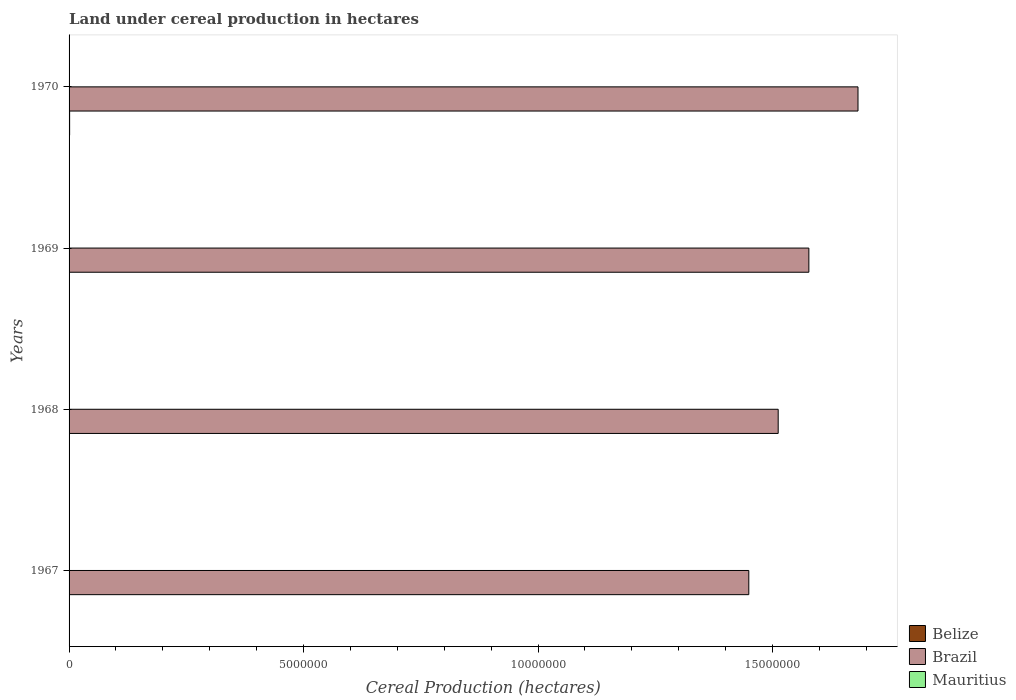How many different coloured bars are there?
Make the answer very short. 3. How many groups of bars are there?
Offer a very short reply. 4. Are the number of bars per tick equal to the number of legend labels?
Provide a succinct answer. Yes. How many bars are there on the 2nd tick from the top?
Ensure brevity in your answer.  3. How many bars are there on the 2nd tick from the bottom?
Ensure brevity in your answer.  3. What is the label of the 3rd group of bars from the top?
Provide a short and direct response. 1968. What is the land under cereal production in Mauritius in 1968?
Make the answer very short. 205. Across all years, what is the maximum land under cereal production in Brazil?
Provide a succinct answer. 1.68e+07. Across all years, what is the minimum land under cereal production in Belize?
Provide a short and direct response. 8102. In which year was the land under cereal production in Mauritius minimum?
Your response must be concise. 1968. What is the total land under cereal production in Belize in the graph?
Offer a very short reply. 3.72e+04. What is the difference between the land under cereal production in Belize in 1968 and that in 1969?
Provide a succinct answer. -375. What is the difference between the land under cereal production in Mauritius in 1967 and the land under cereal production in Belize in 1969?
Your answer should be compact. -8517. What is the average land under cereal production in Mauritius per year?
Keep it short and to the point. 359. In the year 1968, what is the difference between the land under cereal production in Brazil and land under cereal production in Belize?
Offer a terse response. 1.51e+07. In how many years, is the land under cereal production in Brazil greater than 3000000 hectares?
Keep it short and to the point. 4. What is the ratio of the land under cereal production in Mauritius in 1967 to that in 1968?
Your answer should be compact. 1.31. What is the difference between the highest and the second highest land under cereal production in Brazil?
Give a very brief answer. 1.05e+06. What is the difference between the highest and the lowest land under cereal production in Belize?
Ensure brevity in your answer.  3790. Is the sum of the land under cereal production in Mauritius in 1968 and 1969 greater than the maximum land under cereal production in Belize across all years?
Give a very brief answer. No. What does the 2nd bar from the top in 1969 represents?
Provide a short and direct response. Brazil. What does the 1st bar from the bottom in 1967 represents?
Your response must be concise. Belize. How many bars are there?
Provide a succinct answer. 12. How many years are there in the graph?
Keep it short and to the point. 4. Are the values on the major ticks of X-axis written in scientific E-notation?
Ensure brevity in your answer.  No. How many legend labels are there?
Offer a very short reply. 3. How are the legend labels stacked?
Offer a very short reply. Vertical. What is the title of the graph?
Offer a very short reply. Land under cereal production in hectares. Does "Slovak Republic" appear as one of the legend labels in the graph?
Provide a succinct answer. No. What is the label or title of the X-axis?
Make the answer very short. Cereal Production (hectares). What is the Cereal Production (hectares) of Belize in 1967?
Keep it short and to the point. 8102. What is the Cereal Production (hectares) of Brazil in 1967?
Ensure brevity in your answer.  1.45e+07. What is the Cereal Production (hectares) in Mauritius in 1967?
Ensure brevity in your answer.  268. What is the Cereal Production (hectares) of Belize in 1968?
Ensure brevity in your answer.  8410. What is the Cereal Production (hectares) of Brazil in 1968?
Your answer should be very brief. 1.51e+07. What is the Cereal Production (hectares) in Mauritius in 1968?
Provide a succinct answer. 205. What is the Cereal Production (hectares) in Belize in 1969?
Provide a succinct answer. 8785. What is the Cereal Production (hectares) in Brazil in 1969?
Give a very brief answer. 1.58e+07. What is the Cereal Production (hectares) in Mauritius in 1969?
Keep it short and to the point. 446. What is the Cereal Production (hectares) in Belize in 1970?
Make the answer very short. 1.19e+04. What is the Cereal Production (hectares) of Brazil in 1970?
Offer a terse response. 1.68e+07. What is the Cereal Production (hectares) of Mauritius in 1970?
Make the answer very short. 517. Across all years, what is the maximum Cereal Production (hectares) of Belize?
Make the answer very short. 1.19e+04. Across all years, what is the maximum Cereal Production (hectares) of Brazil?
Ensure brevity in your answer.  1.68e+07. Across all years, what is the maximum Cereal Production (hectares) in Mauritius?
Provide a short and direct response. 517. Across all years, what is the minimum Cereal Production (hectares) in Belize?
Offer a terse response. 8102. Across all years, what is the minimum Cereal Production (hectares) of Brazil?
Offer a terse response. 1.45e+07. Across all years, what is the minimum Cereal Production (hectares) in Mauritius?
Your response must be concise. 205. What is the total Cereal Production (hectares) in Belize in the graph?
Your answer should be compact. 3.72e+04. What is the total Cereal Production (hectares) of Brazil in the graph?
Give a very brief answer. 6.22e+07. What is the total Cereal Production (hectares) of Mauritius in the graph?
Give a very brief answer. 1436. What is the difference between the Cereal Production (hectares) of Belize in 1967 and that in 1968?
Offer a terse response. -308. What is the difference between the Cereal Production (hectares) of Brazil in 1967 and that in 1968?
Ensure brevity in your answer.  -6.27e+05. What is the difference between the Cereal Production (hectares) in Belize in 1967 and that in 1969?
Make the answer very short. -683. What is the difference between the Cereal Production (hectares) in Brazil in 1967 and that in 1969?
Keep it short and to the point. -1.28e+06. What is the difference between the Cereal Production (hectares) in Mauritius in 1967 and that in 1969?
Make the answer very short. -178. What is the difference between the Cereal Production (hectares) in Belize in 1967 and that in 1970?
Keep it short and to the point. -3790. What is the difference between the Cereal Production (hectares) of Brazil in 1967 and that in 1970?
Make the answer very short. -2.33e+06. What is the difference between the Cereal Production (hectares) of Mauritius in 1967 and that in 1970?
Your answer should be very brief. -249. What is the difference between the Cereal Production (hectares) of Belize in 1968 and that in 1969?
Keep it short and to the point. -375. What is the difference between the Cereal Production (hectares) in Brazil in 1968 and that in 1969?
Your response must be concise. -6.54e+05. What is the difference between the Cereal Production (hectares) of Mauritius in 1968 and that in 1969?
Your answer should be compact. -241. What is the difference between the Cereal Production (hectares) in Belize in 1968 and that in 1970?
Give a very brief answer. -3482. What is the difference between the Cereal Production (hectares) in Brazil in 1968 and that in 1970?
Keep it short and to the point. -1.70e+06. What is the difference between the Cereal Production (hectares) in Mauritius in 1968 and that in 1970?
Provide a succinct answer. -312. What is the difference between the Cereal Production (hectares) of Belize in 1969 and that in 1970?
Offer a very short reply. -3107. What is the difference between the Cereal Production (hectares) of Brazil in 1969 and that in 1970?
Offer a very short reply. -1.05e+06. What is the difference between the Cereal Production (hectares) in Mauritius in 1969 and that in 1970?
Offer a very short reply. -71. What is the difference between the Cereal Production (hectares) in Belize in 1967 and the Cereal Production (hectares) in Brazil in 1968?
Your response must be concise. -1.51e+07. What is the difference between the Cereal Production (hectares) of Belize in 1967 and the Cereal Production (hectares) of Mauritius in 1968?
Your response must be concise. 7897. What is the difference between the Cereal Production (hectares) of Brazil in 1967 and the Cereal Production (hectares) of Mauritius in 1968?
Provide a succinct answer. 1.45e+07. What is the difference between the Cereal Production (hectares) of Belize in 1967 and the Cereal Production (hectares) of Brazil in 1969?
Your answer should be very brief. -1.58e+07. What is the difference between the Cereal Production (hectares) of Belize in 1967 and the Cereal Production (hectares) of Mauritius in 1969?
Your response must be concise. 7656. What is the difference between the Cereal Production (hectares) in Brazil in 1967 and the Cereal Production (hectares) in Mauritius in 1969?
Ensure brevity in your answer.  1.45e+07. What is the difference between the Cereal Production (hectares) of Belize in 1967 and the Cereal Production (hectares) of Brazil in 1970?
Provide a succinct answer. -1.68e+07. What is the difference between the Cereal Production (hectares) in Belize in 1967 and the Cereal Production (hectares) in Mauritius in 1970?
Offer a terse response. 7585. What is the difference between the Cereal Production (hectares) in Brazil in 1967 and the Cereal Production (hectares) in Mauritius in 1970?
Ensure brevity in your answer.  1.45e+07. What is the difference between the Cereal Production (hectares) in Belize in 1968 and the Cereal Production (hectares) in Brazil in 1969?
Your answer should be very brief. -1.58e+07. What is the difference between the Cereal Production (hectares) of Belize in 1968 and the Cereal Production (hectares) of Mauritius in 1969?
Your response must be concise. 7964. What is the difference between the Cereal Production (hectares) of Brazil in 1968 and the Cereal Production (hectares) of Mauritius in 1969?
Your answer should be compact. 1.51e+07. What is the difference between the Cereal Production (hectares) in Belize in 1968 and the Cereal Production (hectares) in Brazil in 1970?
Offer a very short reply. -1.68e+07. What is the difference between the Cereal Production (hectares) of Belize in 1968 and the Cereal Production (hectares) of Mauritius in 1970?
Provide a succinct answer. 7893. What is the difference between the Cereal Production (hectares) in Brazil in 1968 and the Cereal Production (hectares) in Mauritius in 1970?
Your answer should be very brief. 1.51e+07. What is the difference between the Cereal Production (hectares) in Belize in 1969 and the Cereal Production (hectares) in Brazil in 1970?
Make the answer very short. -1.68e+07. What is the difference between the Cereal Production (hectares) of Belize in 1969 and the Cereal Production (hectares) of Mauritius in 1970?
Your answer should be compact. 8268. What is the difference between the Cereal Production (hectares) in Brazil in 1969 and the Cereal Production (hectares) in Mauritius in 1970?
Provide a succinct answer. 1.58e+07. What is the average Cereal Production (hectares) of Belize per year?
Your response must be concise. 9297.25. What is the average Cereal Production (hectares) of Brazil per year?
Your answer should be very brief. 1.56e+07. What is the average Cereal Production (hectares) in Mauritius per year?
Your answer should be compact. 359. In the year 1967, what is the difference between the Cereal Production (hectares) of Belize and Cereal Production (hectares) of Brazil?
Ensure brevity in your answer.  -1.45e+07. In the year 1967, what is the difference between the Cereal Production (hectares) of Belize and Cereal Production (hectares) of Mauritius?
Ensure brevity in your answer.  7834. In the year 1967, what is the difference between the Cereal Production (hectares) of Brazil and Cereal Production (hectares) of Mauritius?
Your response must be concise. 1.45e+07. In the year 1968, what is the difference between the Cereal Production (hectares) of Belize and Cereal Production (hectares) of Brazil?
Your answer should be very brief. -1.51e+07. In the year 1968, what is the difference between the Cereal Production (hectares) of Belize and Cereal Production (hectares) of Mauritius?
Make the answer very short. 8205. In the year 1968, what is the difference between the Cereal Production (hectares) in Brazil and Cereal Production (hectares) in Mauritius?
Offer a terse response. 1.51e+07. In the year 1969, what is the difference between the Cereal Production (hectares) of Belize and Cereal Production (hectares) of Brazil?
Provide a succinct answer. -1.58e+07. In the year 1969, what is the difference between the Cereal Production (hectares) of Belize and Cereal Production (hectares) of Mauritius?
Your answer should be very brief. 8339. In the year 1969, what is the difference between the Cereal Production (hectares) of Brazil and Cereal Production (hectares) of Mauritius?
Your answer should be very brief. 1.58e+07. In the year 1970, what is the difference between the Cereal Production (hectares) of Belize and Cereal Production (hectares) of Brazil?
Your answer should be very brief. -1.68e+07. In the year 1970, what is the difference between the Cereal Production (hectares) in Belize and Cereal Production (hectares) in Mauritius?
Ensure brevity in your answer.  1.14e+04. In the year 1970, what is the difference between the Cereal Production (hectares) in Brazil and Cereal Production (hectares) in Mauritius?
Offer a very short reply. 1.68e+07. What is the ratio of the Cereal Production (hectares) of Belize in 1967 to that in 1968?
Provide a short and direct response. 0.96. What is the ratio of the Cereal Production (hectares) of Brazil in 1967 to that in 1968?
Offer a terse response. 0.96. What is the ratio of the Cereal Production (hectares) of Mauritius in 1967 to that in 1968?
Your answer should be very brief. 1.31. What is the ratio of the Cereal Production (hectares) of Belize in 1967 to that in 1969?
Provide a succinct answer. 0.92. What is the ratio of the Cereal Production (hectares) in Brazil in 1967 to that in 1969?
Make the answer very short. 0.92. What is the ratio of the Cereal Production (hectares) in Mauritius in 1967 to that in 1969?
Make the answer very short. 0.6. What is the ratio of the Cereal Production (hectares) in Belize in 1967 to that in 1970?
Make the answer very short. 0.68. What is the ratio of the Cereal Production (hectares) of Brazil in 1967 to that in 1970?
Provide a succinct answer. 0.86. What is the ratio of the Cereal Production (hectares) in Mauritius in 1967 to that in 1970?
Your answer should be compact. 0.52. What is the ratio of the Cereal Production (hectares) of Belize in 1968 to that in 1969?
Your response must be concise. 0.96. What is the ratio of the Cereal Production (hectares) of Brazil in 1968 to that in 1969?
Your answer should be compact. 0.96. What is the ratio of the Cereal Production (hectares) in Mauritius in 1968 to that in 1969?
Your answer should be very brief. 0.46. What is the ratio of the Cereal Production (hectares) in Belize in 1968 to that in 1970?
Your response must be concise. 0.71. What is the ratio of the Cereal Production (hectares) in Brazil in 1968 to that in 1970?
Your answer should be compact. 0.9. What is the ratio of the Cereal Production (hectares) of Mauritius in 1968 to that in 1970?
Offer a very short reply. 0.4. What is the ratio of the Cereal Production (hectares) in Belize in 1969 to that in 1970?
Ensure brevity in your answer.  0.74. What is the ratio of the Cereal Production (hectares) of Brazil in 1969 to that in 1970?
Keep it short and to the point. 0.94. What is the ratio of the Cereal Production (hectares) in Mauritius in 1969 to that in 1970?
Provide a succinct answer. 0.86. What is the difference between the highest and the second highest Cereal Production (hectares) of Belize?
Your response must be concise. 3107. What is the difference between the highest and the second highest Cereal Production (hectares) in Brazil?
Make the answer very short. 1.05e+06. What is the difference between the highest and the lowest Cereal Production (hectares) in Belize?
Your answer should be compact. 3790. What is the difference between the highest and the lowest Cereal Production (hectares) of Brazil?
Your answer should be very brief. 2.33e+06. What is the difference between the highest and the lowest Cereal Production (hectares) of Mauritius?
Offer a very short reply. 312. 